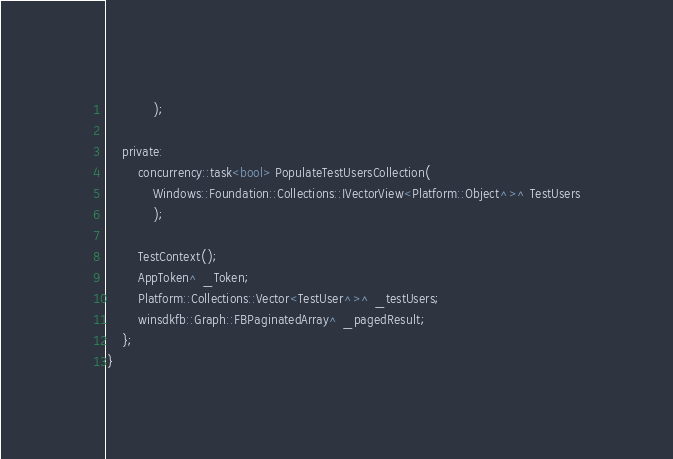Convert code to text. <code><loc_0><loc_0><loc_500><loc_500><_C_>            );

    private:
        concurrency::task<bool> PopulateTestUsersCollection(
            Windows::Foundation::Collections::IVectorView<Platform::Object^>^ TestUsers
            );

        TestContext();
        AppToken^ _Token;
        Platform::Collections::Vector<TestUser^>^ _testUsers;
        winsdkfb::Graph::FBPaginatedArray^ _pagedResult;
    };
}
</code> 